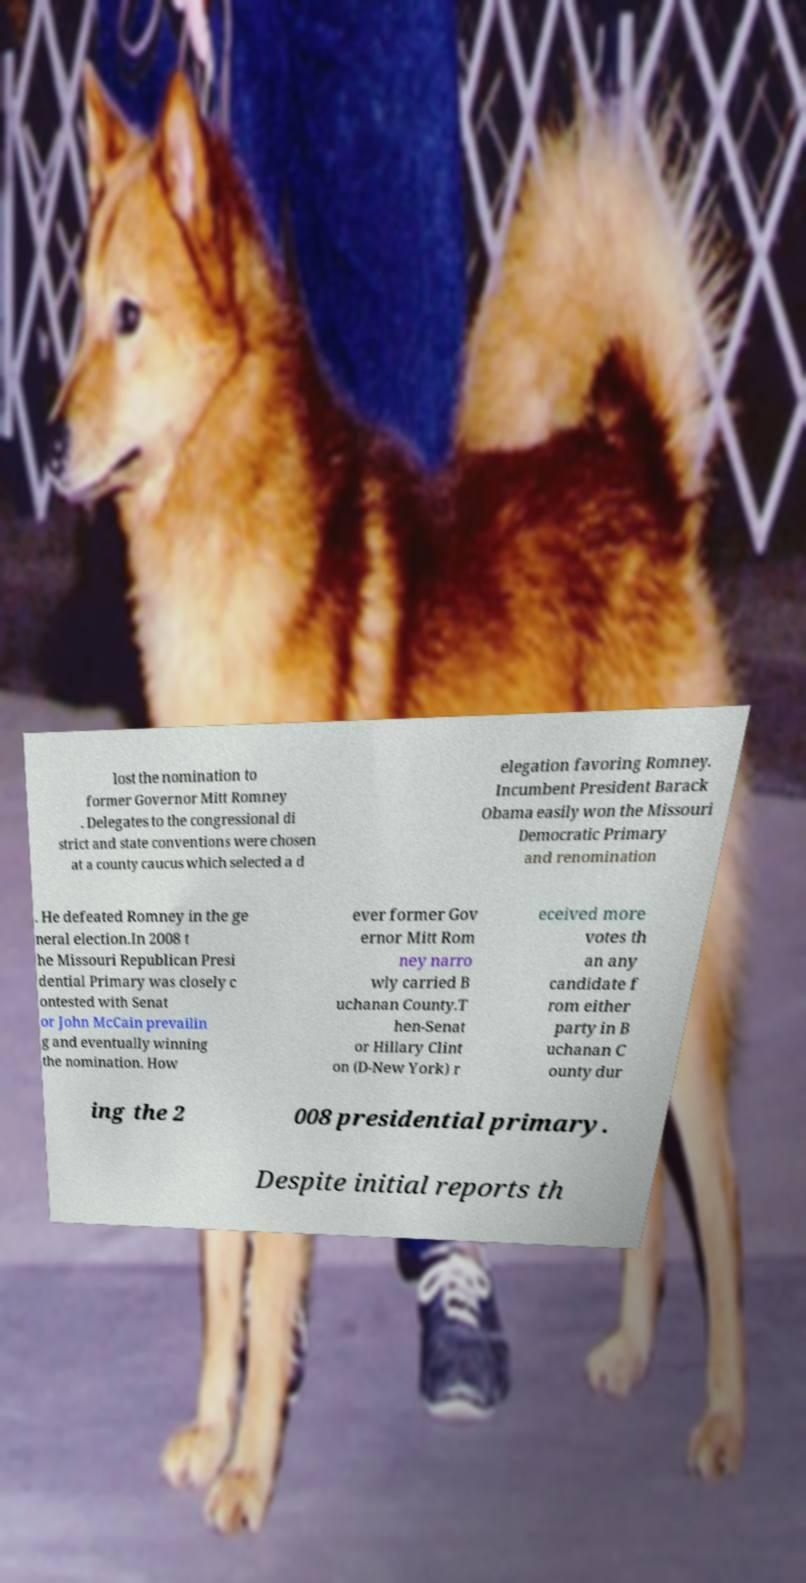Can you read and provide the text displayed in the image?This photo seems to have some interesting text. Can you extract and type it out for me? lost the nomination to former Governor Mitt Romney . Delegates to the congressional di strict and state conventions were chosen at a county caucus which selected a d elegation favoring Romney. Incumbent President Barack Obama easily won the Missouri Democratic Primary and renomination . He defeated Romney in the ge neral election.In 2008 t he Missouri Republican Presi dential Primary was closely c ontested with Senat or John McCain prevailin g and eventually winning the nomination. How ever former Gov ernor Mitt Rom ney narro wly carried B uchanan County.T hen-Senat or Hillary Clint on (D-New York) r eceived more votes th an any candidate f rom either party in B uchanan C ounty dur ing the 2 008 presidential primary. Despite initial reports th 